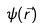Convert formula to latex. <formula><loc_0><loc_0><loc_500><loc_500>\psi ( { \vec { r } } )</formula> 